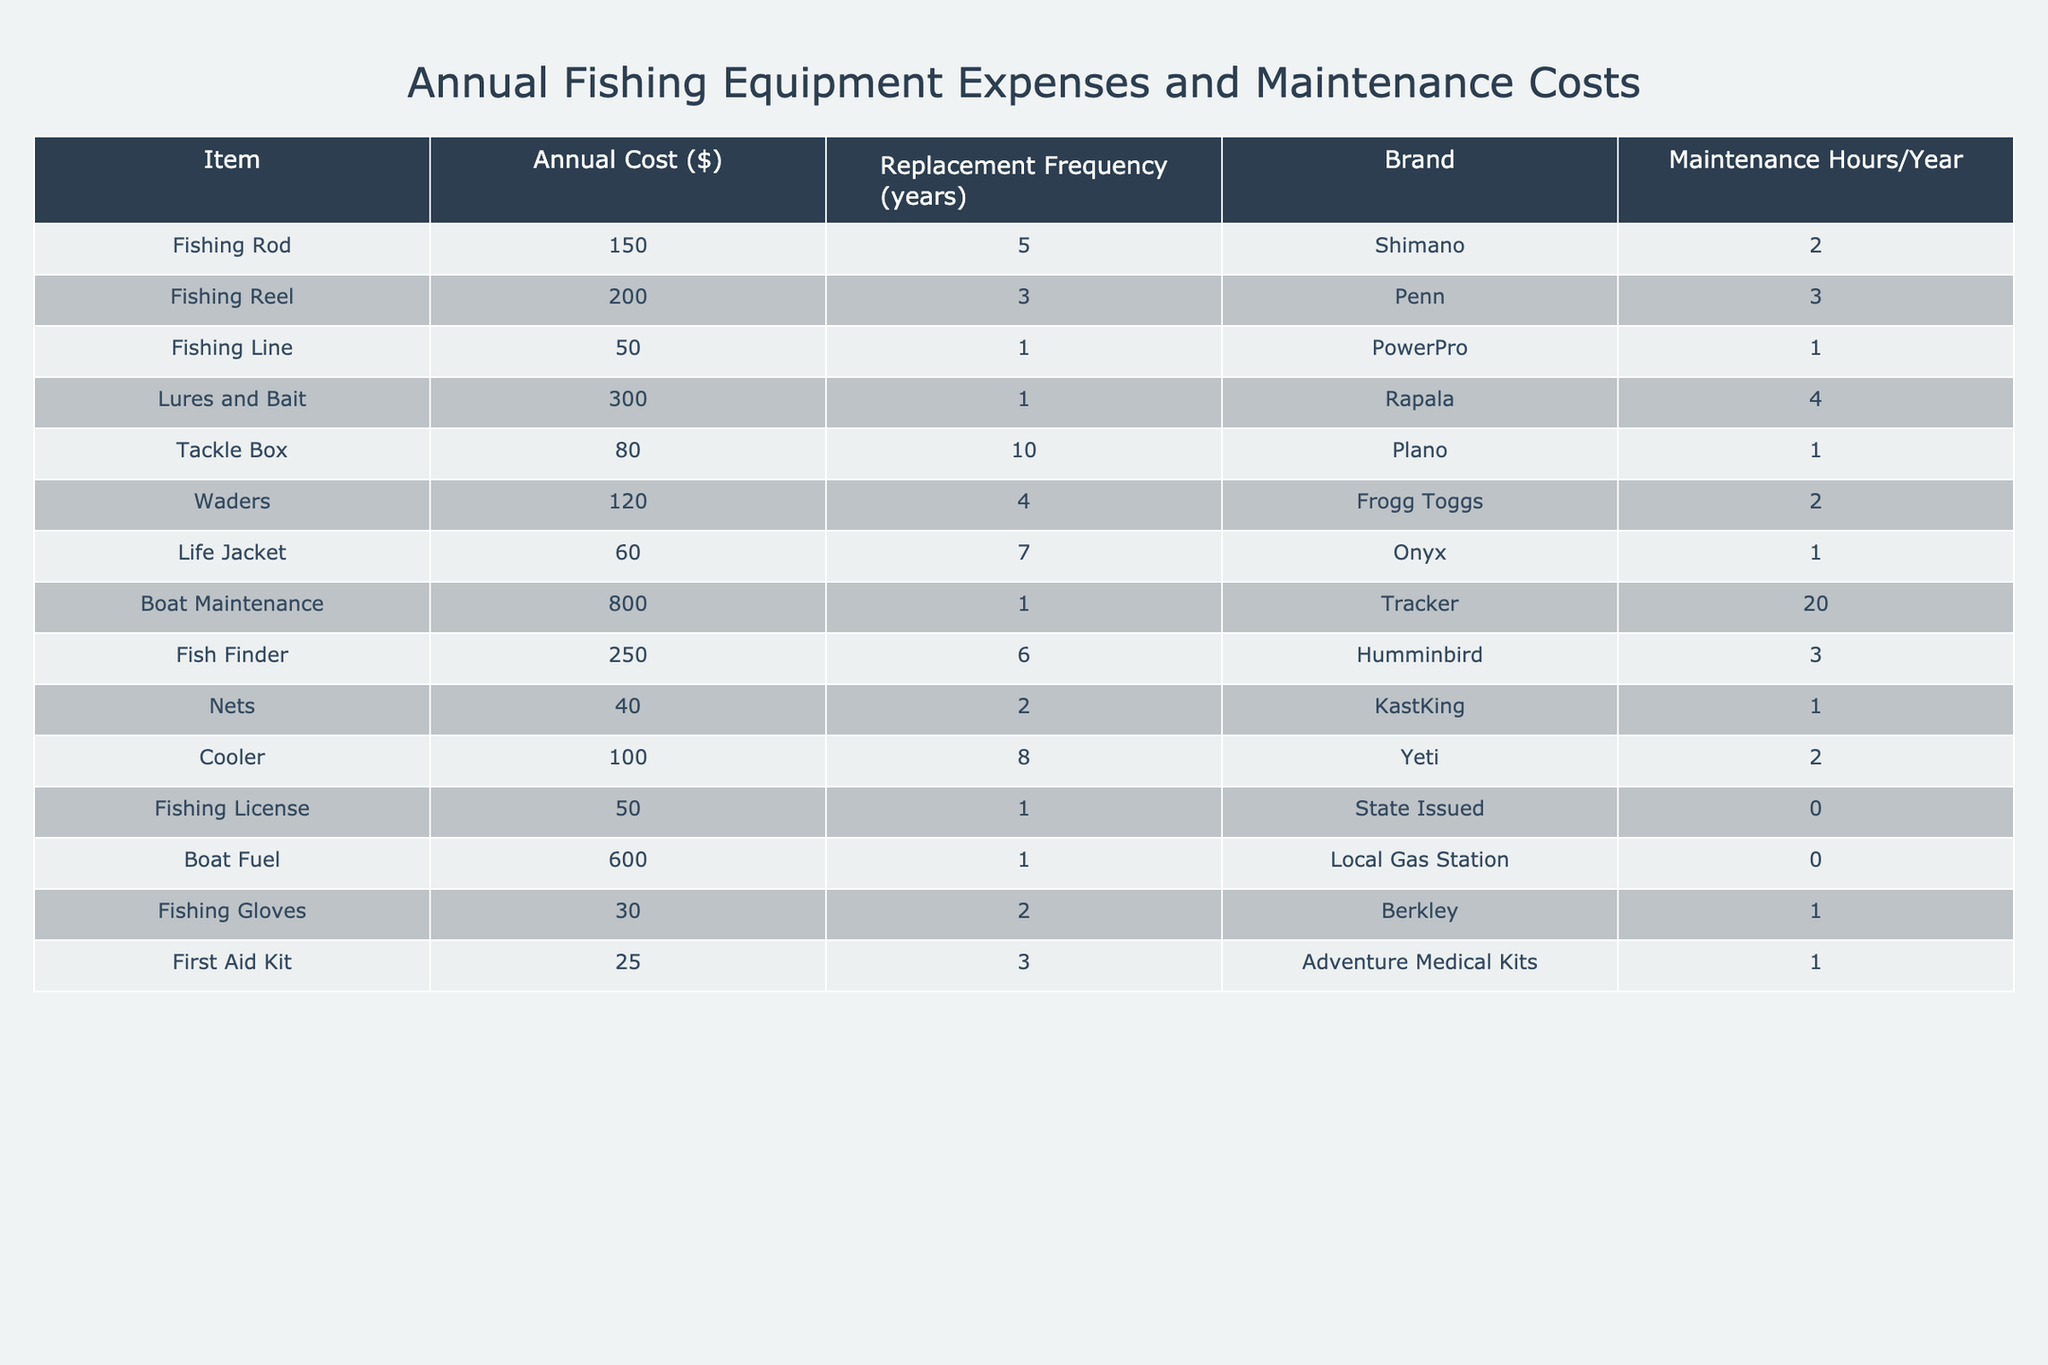What is the total annual cost of all fishing equipment? To find the total annual cost, we sum all the values in the "Annual Cost ($)" column: 150 + 200 + 50 + 300 + 80 + 120 + 60 + 800 + 250 + 40 + 100 + 50 + 600 + 30 + 25 = 2,155.
Answer: 2155 How often does a fishing reel need to be replaced? The "Replacement Frequency (years)" for a fishing reel in the table is listed as 3 years.
Answer: 3 years Which item has the highest annual cost? By comparing the values in the "Annual Cost ($)" column, we see that "Boat Maintenance" has the highest cost at $800.
Answer: Boat Maintenance What is the average cost of the fishing equipment? To calculate the average, we first sum all the annual costs to get 2155 and then divide by the number of items, which is 15. So, 2155 / 15 = 143.67.
Answer: 143.67 Are fishing gloves more expensive than a fishing line? The cost of fishing gloves is $30 and fishing line is $50; since 30 is less than 50, it is false that fishing gloves are more expensive.
Answer: No What is the total maintenance cost for equipment that requires maintenance every year? The items that require maintenance every year are "Fishing Line", "Lures and Bait", "Boat Maintenance", "Fishing License", and "Boat Fuel". Their costs are 50 + 300 + 800 + 50 + 600 = 1800.
Answer: 1800 How many hours per year does fishing equipment maintenance require in total? To find the total maintenance hours, we add the "Maintenance Hours/Year" values of all items: 2 + 3 + 1 + 4 + 1 + 2 + 1 + 20 + 3 + 1 + 2 + 0 + 0 + 1 + 1 = 38.
Answer: 38 What percentage of the total annual cost is spent on boat maintenance? Boat maintenance costs $800, and the total cost is $2155. To calculate the percentage: (800 / 2155) * 100 = 37.09%.
Answer: 37.09% Which brand of fishing equipment has the lowest annual expense? The item with the lowest annual cost is "Fishing Gloves" at $30, and the brand is "Berkley".
Answer: Berkley What is the combined replacement frequency of the fishing rod and fish finder? The fishing rod has a replacement frequency of 5 years, while the fish finder has 6 years, so we sum them: 5 + 6 = 11.
Answer: 11 